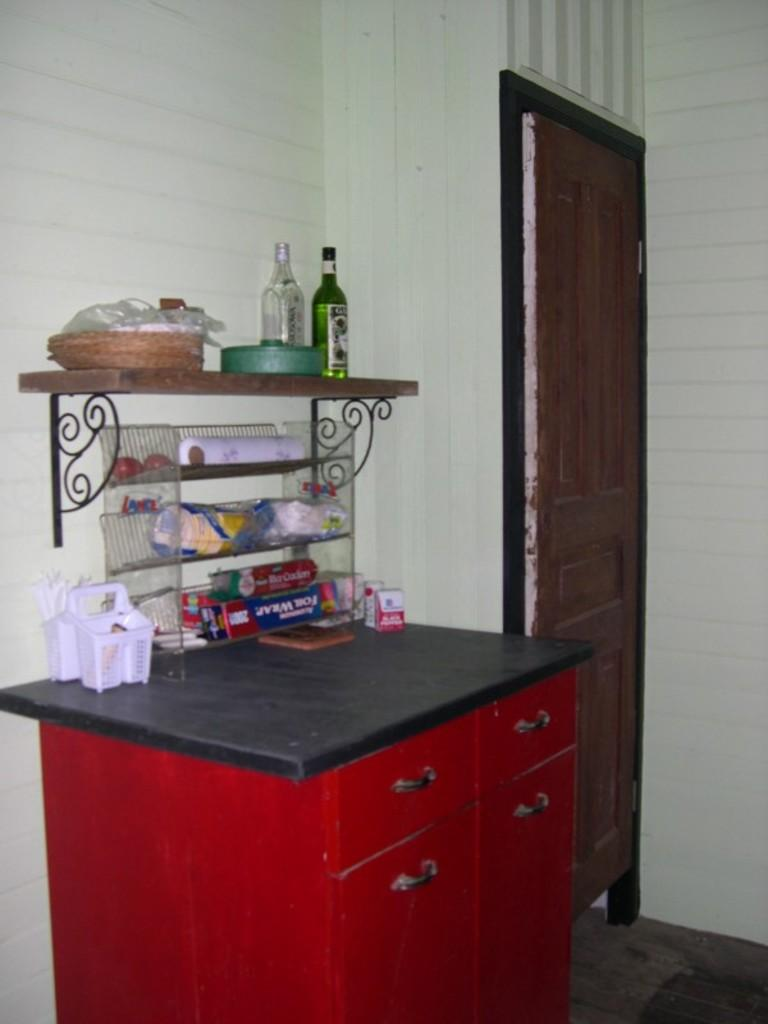What color is the cupboard in the image? The cupboard in the image is red. What is located above the red cupboard? There is a basket and a small rack with things above the red cupboard. What can be seen on the wood table in the image? There is a bottle and a basket on the wood table. What type of door is present in the image? There is a wood door in the image. What type of van is parked outside the wood door in the image? There is no van present in the image; it only shows a wood door and other items inside the room. 